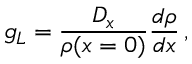<formula> <loc_0><loc_0><loc_500><loc_500>g _ { L } = \frac { D _ { x } } { \rho ( x = 0 ) } \frac { d \rho } { d x } \, ,</formula> 